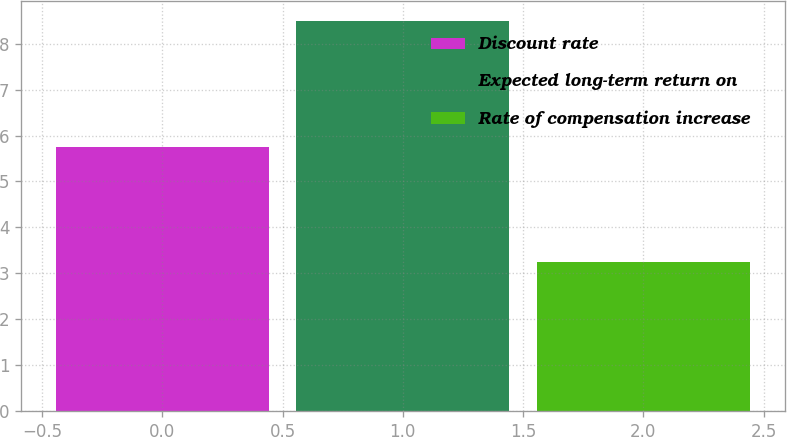Convert chart. <chart><loc_0><loc_0><loc_500><loc_500><bar_chart><fcel>Discount rate<fcel>Expected long-term return on<fcel>Rate of compensation increase<nl><fcel>5.75<fcel>8.5<fcel>3.25<nl></chart> 